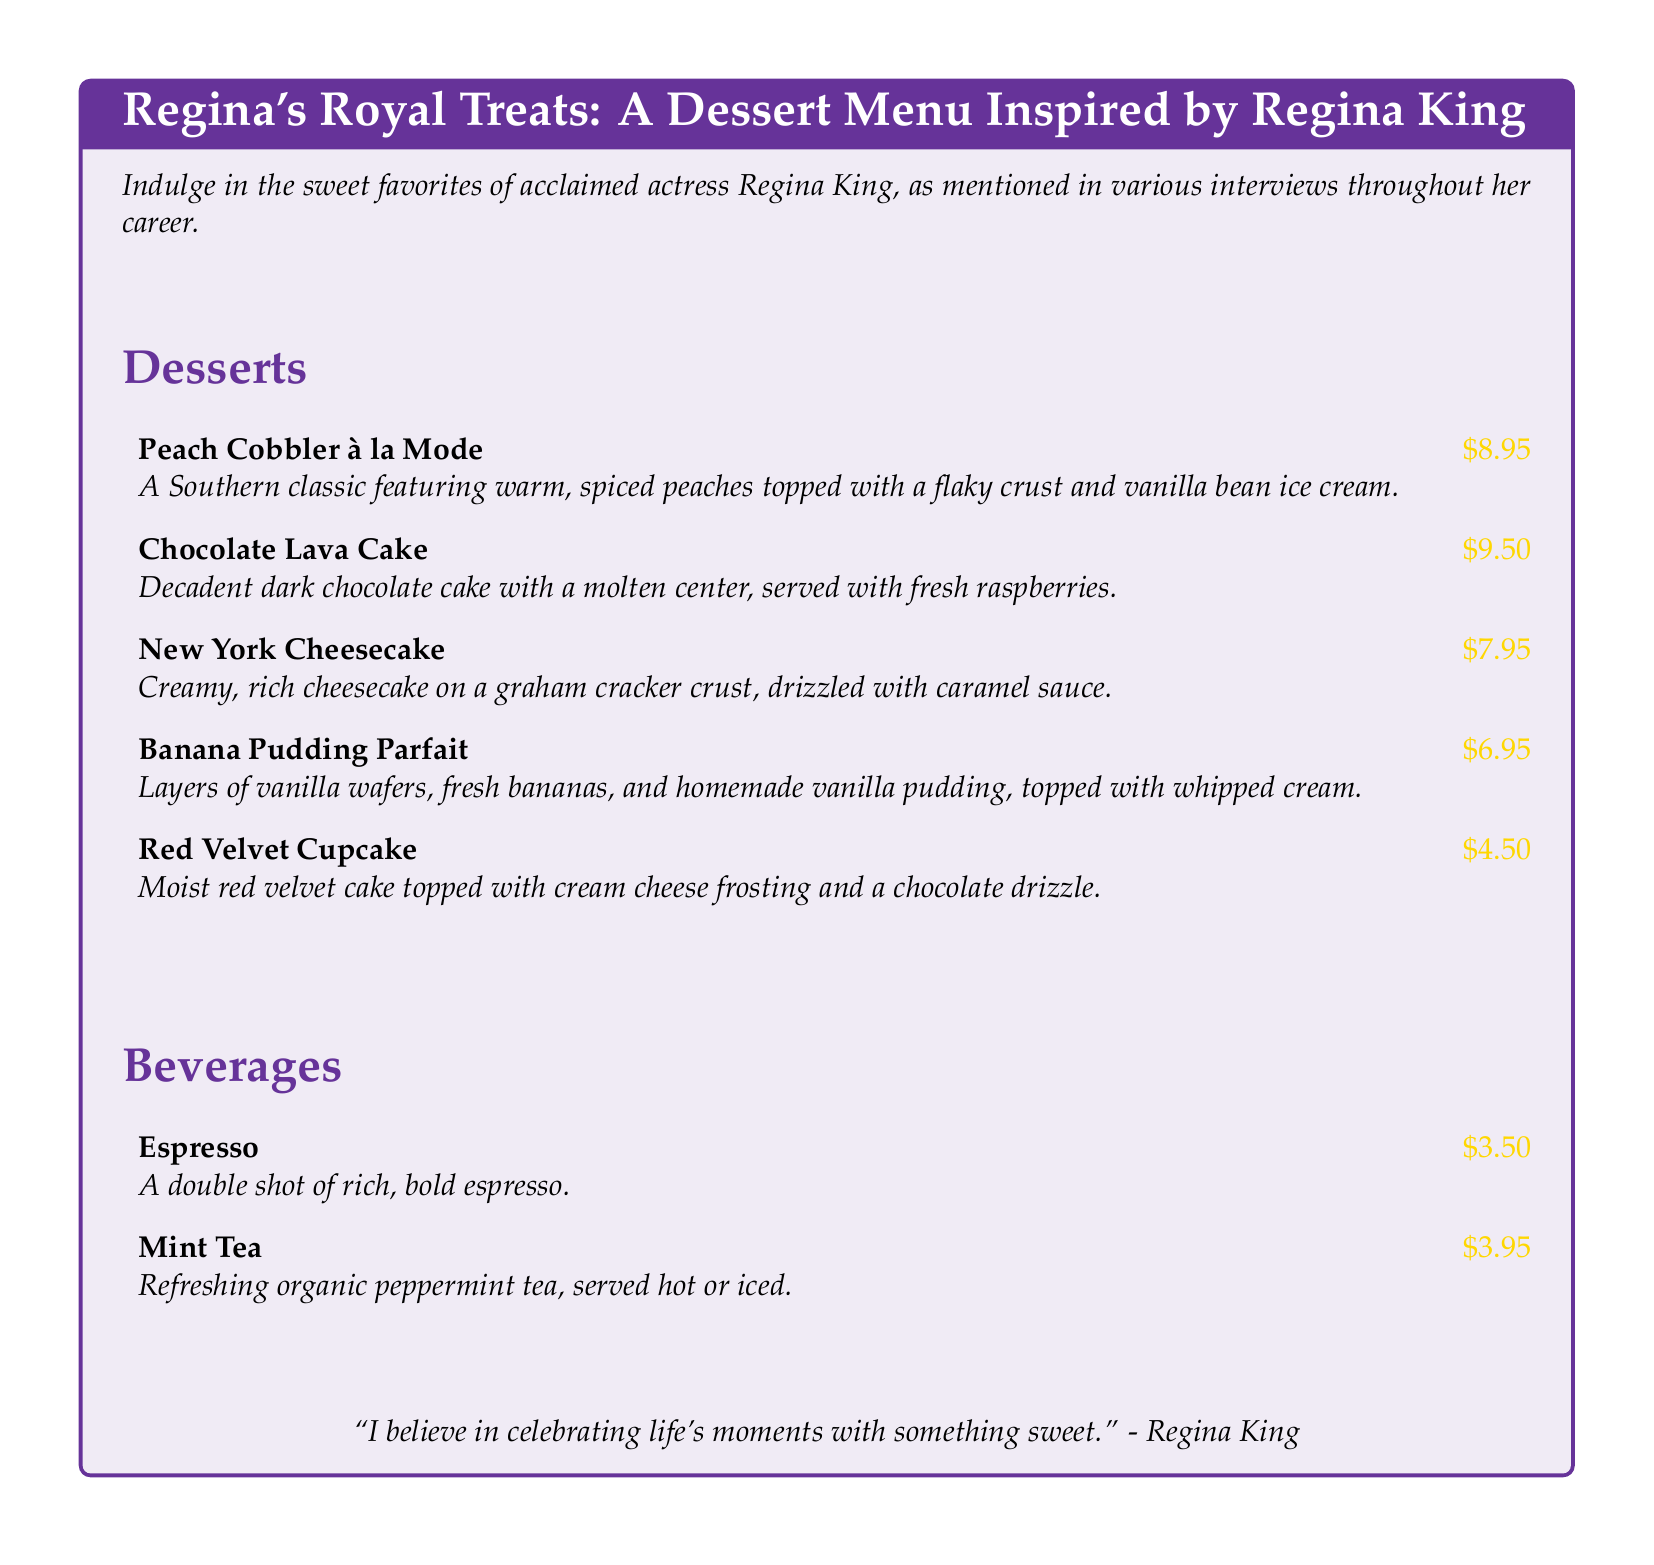What is the price of Peach Cobbler à la Mode? The price for Peach Cobbler à la Mode is listed in the dessert menu section of the document.
Answer: $8.95 What type of cake is the Chocolate Lava Cake? The Chocolate Lava Cake is described in the dessert item section as a dark chocolate cake.
Answer: dark chocolate What is the main ingredient in New York Cheesecake's crust? The crust of the New York Cheesecake is a graham cracker crust, as mentioned in the dessert description.
Answer: graham cracker Which dessert has bananas as a key ingredient? The dessert that features bananas is Banana Pudding Parfait, as indicated in the document.
Answer: Banana Pudding Parfait What is included in the Banana Pudding Parfait? The description of the Banana Pudding Parfait lists its layers, which are vanilla wafers, fresh bananas, and homemade vanilla pudding.
Answer: vanilla wafers, fresh bananas, homemade vanilla pudding How many desserts are listed in the menu? The document contains a list of desserts under the Desserts section, totaling five dessert items.
Answer: five What beverage is mentioned as a mint variant? The beverage section includes a refreshing organic peppermint tea, identifying it by its flavor.
Answer: Mint Tea What quote by Regina King is included in the document? The document features a quote attributed to Regina King in the center of the menu, emphasizing the importance of sweets.
Answer: "I believe in celebrating life's moments with something sweet." 